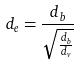<formula> <loc_0><loc_0><loc_500><loc_500>d _ { e } = \frac { d _ { b } } { \sqrt { \frac { d _ { b } } { d _ { v } } } }</formula> 